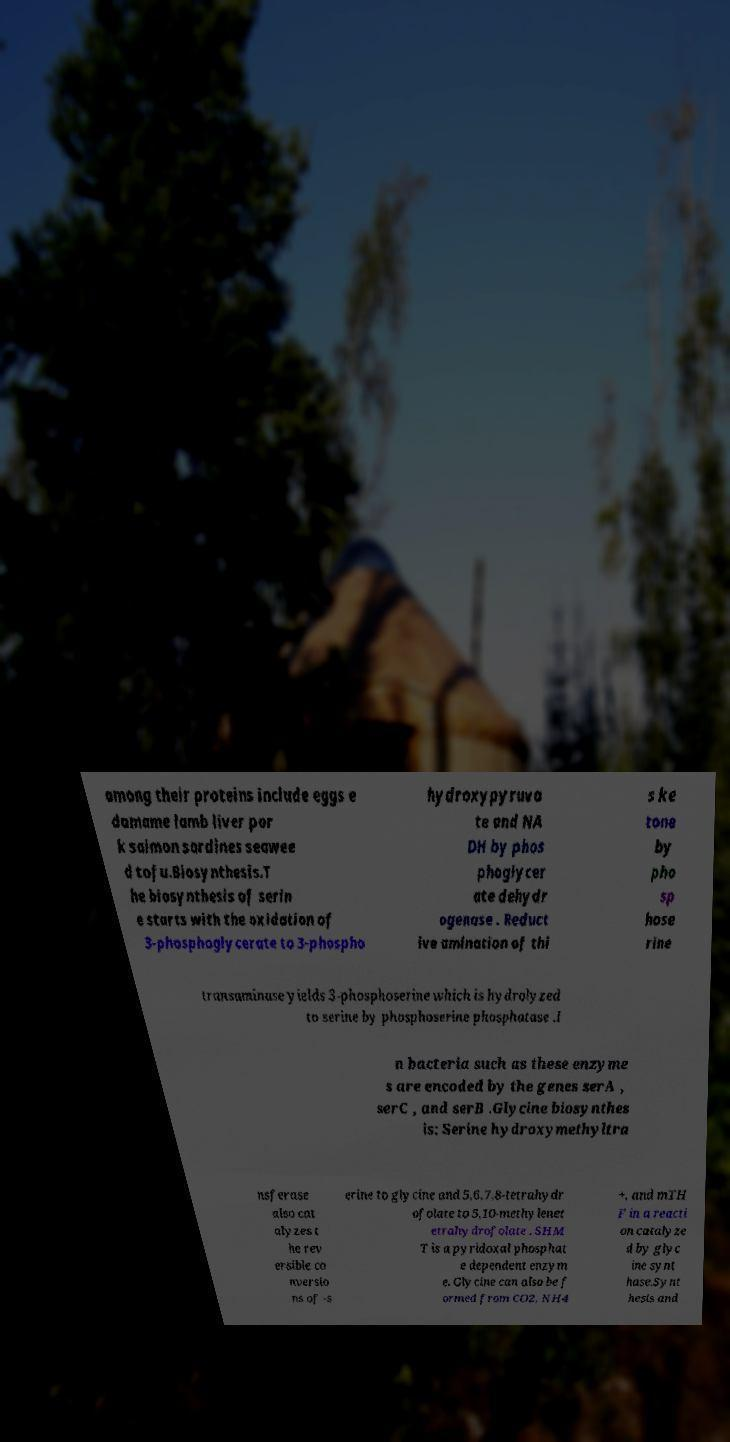Can you read and provide the text displayed in the image?This photo seems to have some interesting text. Can you extract and type it out for me? among their proteins include eggs e damame lamb liver por k salmon sardines seawee d tofu.Biosynthesis.T he biosynthesis of serin e starts with the oxidation of 3-phosphoglycerate to 3-phospho hydroxypyruva te and NA DH by phos phoglycer ate dehydr ogenase . Reduct ive amination of thi s ke tone by pho sp hose rine transaminase yields 3-phosphoserine which is hydrolyzed to serine by phosphoserine phosphatase .I n bacteria such as these enzyme s are encoded by the genes serA , serC , and serB .Glycine biosynthes is: Serine hydroxymethyltra nsferase also cat alyzes t he rev ersible co nversio ns of -s erine to glycine and 5,6,7,8-tetrahydr ofolate to 5,10-methylenet etrahydrofolate . SHM T is a pyridoxal phosphat e dependent enzym e. Glycine can also be f ormed from CO2, NH4 +, and mTH F in a reacti on catalyze d by glyc ine synt hase.Synt hesis and 